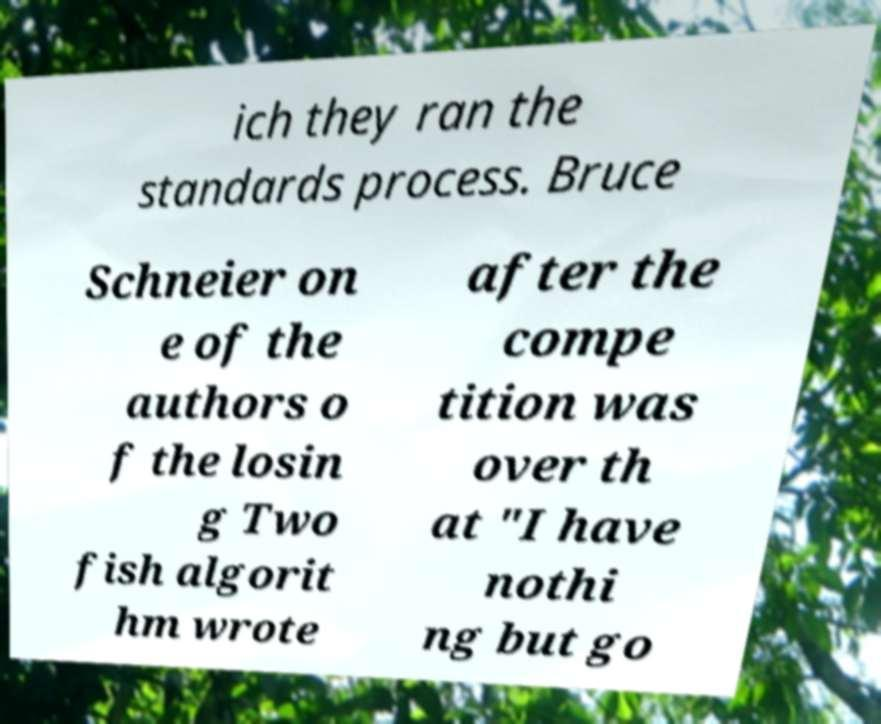Please identify and transcribe the text found in this image. ich they ran the standards process. Bruce Schneier on e of the authors o f the losin g Two fish algorit hm wrote after the compe tition was over th at "I have nothi ng but go 